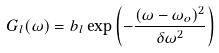Convert formula to latex. <formula><loc_0><loc_0><loc_500><loc_500>G _ { l } ( \omega ) = b _ { l } \exp \left ( - \frac { ( \omega - \omega _ { o } ) ^ { 2 } } { \delta \omega ^ { 2 } } \right )</formula> 